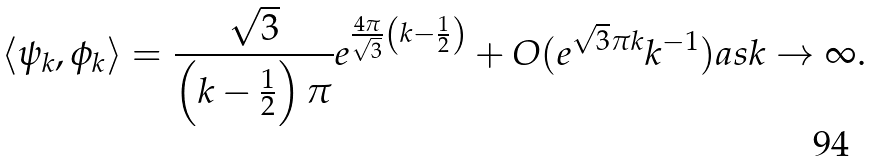<formula> <loc_0><loc_0><loc_500><loc_500>\langle \psi _ { k } , \phi _ { k } \rangle = \frac { \sqrt { 3 } } { \left ( k - \frac { 1 } { 2 } \right ) \pi } e ^ { \frac { 4 \pi } { \sqrt { 3 } } \left ( k - \frac { 1 } { 2 } \right ) } + O ( e ^ { \sqrt { 3 } \pi k } k ^ { - 1 } ) a s k \to \infty .</formula> 